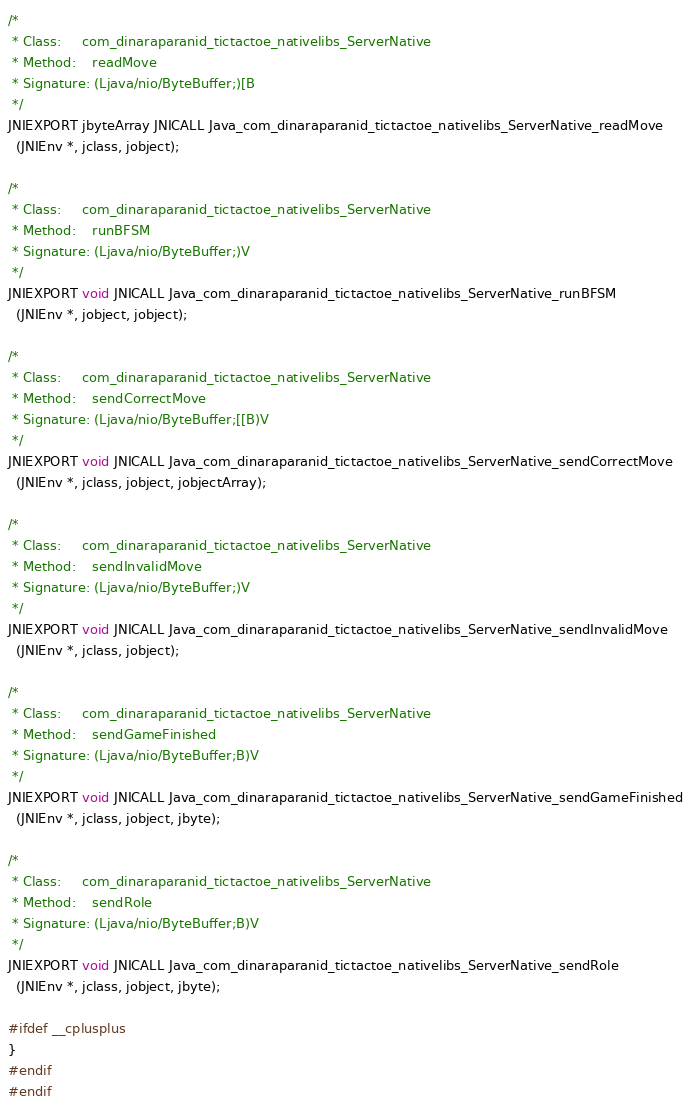Convert code to text. <code><loc_0><loc_0><loc_500><loc_500><_C_>
/*
 * Class:     com_dinaraparanid_tictactoe_nativelibs_ServerNative
 * Method:    readMove
 * Signature: (Ljava/nio/ByteBuffer;)[B
 */
JNIEXPORT jbyteArray JNICALL Java_com_dinaraparanid_tictactoe_nativelibs_ServerNative_readMove
  (JNIEnv *, jclass, jobject);

/*
 * Class:     com_dinaraparanid_tictactoe_nativelibs_ServerNative
 * Method:    runBFSM
 * Signature: (Ljava/nio/ByteBuffer;)V
 */
JNIEXPORT void JNICALL Java_com_dinaraparanid_tictactoe_nativelibs_ServerNative_runBFSM
  (JNIEnv *, jobject, jobject);

/*
 * Class:     com_dinaraparanid_tictactoe_nativelibs_ServerNative
 * Method:    sendCorrectMove
 * Signature: (Ljava/nio/ByteBuffer;[[B)V
 */
JNIEXPORT void JNICALL Java_com_dinaraparanid_tictactoe_nativelibs_ServerNative_sendCorrectMove
  (JNIEnv *, jclass, jobject, jobjectArray);

/*
 * Class:     com_dinaraparanid_tictactoe_nativelibs_ServerNative
 * Method:    sendInvalidMove
 * Signature: (Ljava/nio/ByteBuffer;)V
 */
JNIEXPORT void JNICALL Java_com_dinaraparanid_tictactoe_nativelibs_ServerNative_sendInvalidMove
  (JNIEnv *, jclass, jobject);

/*
 * Class:     com_dinaraparanid_tictactoe_nativelibs_ServerNative
 * Method:    sendGameFinished
 * Signature: (Ljava/nio/ByteBuffer;B)V
 */
JNIEXPORT void JNICALL Java_com_dinaraparanid_tictactoe_nativelibs_ServerNative_sendGameFinished
  (JNIEnv *, jclass, jobject, jbyte);

/*
 * Class:     com_dinaraparanid_tictactoe_nativelibs_ServerNative
 * Method:    sendRole
 * Signature: (Ljava/nio/ByteBuffer;B)V
 */
JNIEXPORT void JNICALL Java_com_dinaraparanid_tictactoe_nativelibs_ServerNative_sendRole
  (JNIEnv *, jclass, jobject, jbyte);

#ifdef __cplusplus
}
#endif
#endif
</code> 